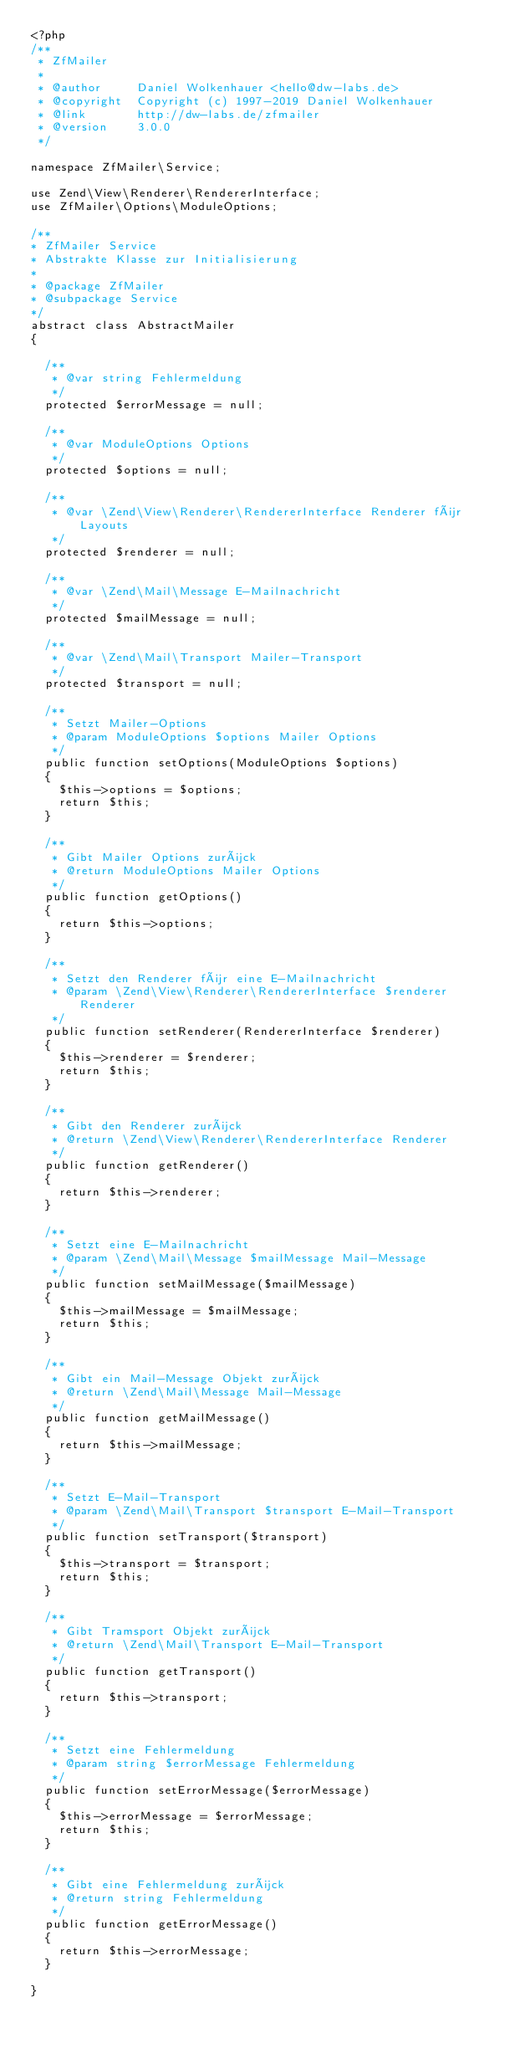Convert code to text. <code><loc_0><loc_0><loc_500><loc_500><_PHP_><?php
/**
 * ZfMailer
 *
 * @author     Daniel Wolkenhauer <hello@dw-labs.de>
 * @copyright  Copyright (c) 1997-2019 Daniel Wolkenhauer
 * @link       http://dw-labs.de/zfmailer
 * @version    3.0.0
 */

namespace ZfMailer\Service;

use Zend\View\Renderer\RendererInterface;
use ZfMailer\Options\ModuleOptions;

/**
* ZfMailer Service
* Abstrakte Klasse zur Initialisierung
* 
* @package ZfMailer
* @subpackage Service
*/
abstract class AbstractMailer
{

  /**
   * @var string Fehlermeldung
   */
  protected $errorMessage = null;

  /**
   * @var ModuleOptions Options
   */
  protected $options = null;
  
  /**
   * @var \Zend\View\Renderer\RendererInterface Renderer für Layouts
   */
  protected $renderer = null;
  
  /**
   * @var \Zend\Mail\Message E-Mailnachricht
   */
  protected $mailMessage = null;
  
  /**
   * @var \Zend\Mail\Transport Mailer-Transport
   */
  protected $transport = null;

  /**
   * Setzt Mailer-Options
   * @param ModuleOptions $options Mailer Options
   */
  public function setOptions(ModuleOptions $options)
  {
    $this->options = $options;
    return $this;
  }

  /**
   * Gibt Mailer Options zurück
   * @return ModuleOptions Mailer Options
   */
  public function getOptions()
  {
    return $this->options;
  }

  /**
   * Setzt den Renderer für eine E-Mailnachricht
   * @param \Zend\View\Renderer\RendererInterface $renderer Renderer
   */
  public function setRenderer(RendererInterface $renderer)
  {
    $this->renderer = $renderer;
    return $this;
  }

  /**
   * Gibt den Renderer zurück
   * @return \Zend\View\Renderer\RendererInterface Renderer
   */
  public function getRenderer()
  {
    return $this->renderer;
  }

  /**
   * Setzt eine E-Mailnachricht
   * @param \Zend\Mail\Message $mailMessage Mail-Message
   */
  public function setMailMessage($mailMessage)
  {
    $this->mailMessage = $mailMessage;
    return $this;
  }

  /**
   * Gibt ein Mail-Message Objekt zurück
   * @return \Zend\Mail\Message Mail-Message
   */
  public function getMailMessage()
  {
    return $this->mailMessage;
  }

  /**
   * Setzt E-Mail-Transport
   * @param \Zend\Mail\Transport $transport E-Mail-Transport
   */
  public function setTransport($transport)
  {
    $this->transport = $transport;
    return $this;
  }

  /**
   * Gibt Tramsport Objekt zurück
   * @return \Zend\Mail\Transport E-Mail-Transport
   */
  public function getTransport()
  {
    return $this->transport;
  }

  /**
   * Setzt eine Fehlermeldung
   * @param string $errorMessage Fehlermeldung
   */
  public function setErrorMessage($errorMessage)
  {
    $this->errorMessage = $errorMessage;
    return $this;
  }

  /**
   * Gibt eine Fehlermeldung zurück
   * @return string Fehlermeldung
   */
  public function getErrorMessage()
  {
    return $this->errorMessage;
  }

}
</code> 